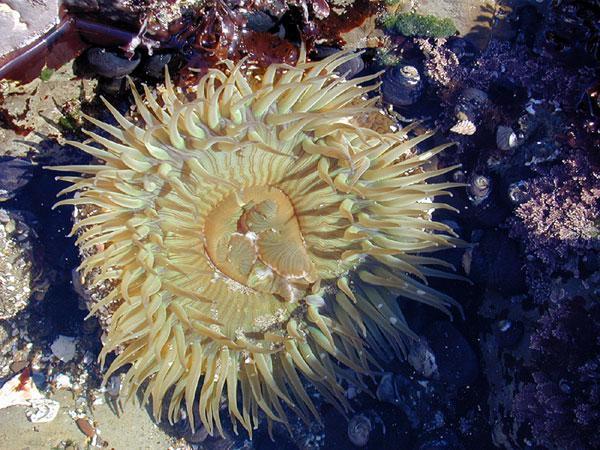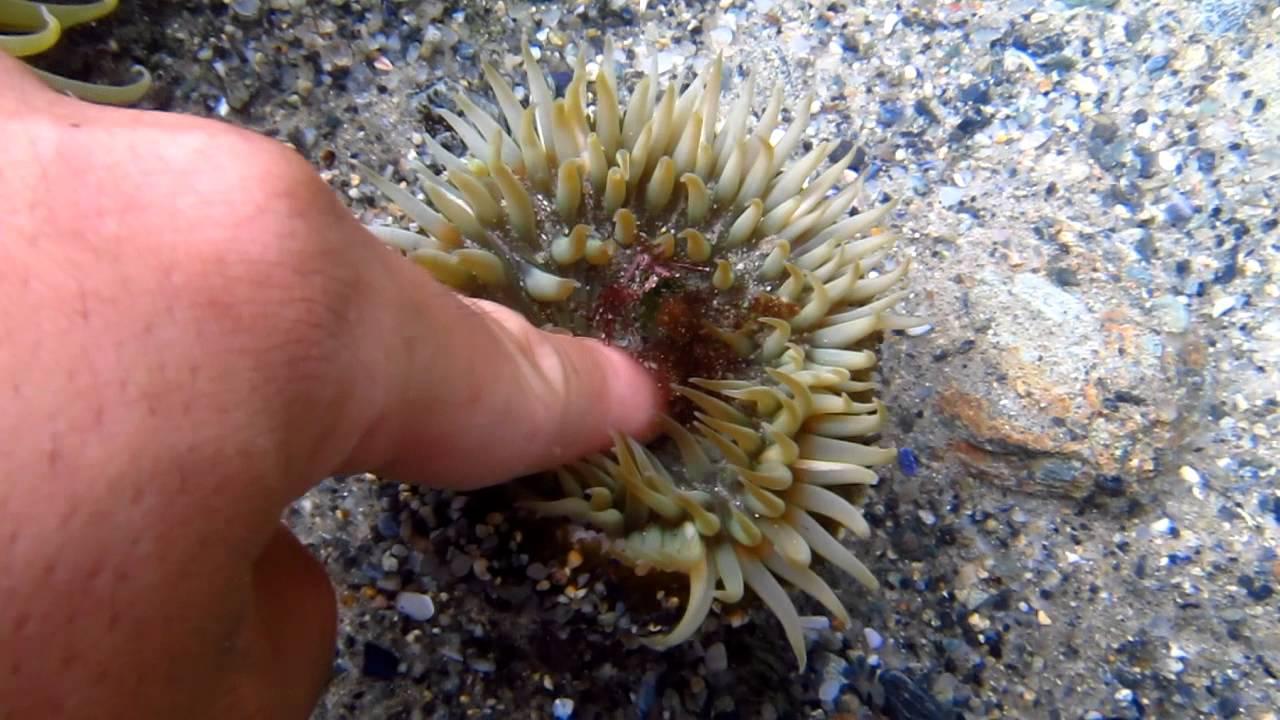The first image is the image on the left, the second image is the image on the right. Assess this claim about the two images: "the anemone in one of the images is very wide". Correct or not? Answer yes or no. No. The first image is the image on the left, the second image is the image on the right. Considering the images on both sides, is "An image shows a neutral-colored anemone with sky blue background." valid? Answer yes or no. No. 